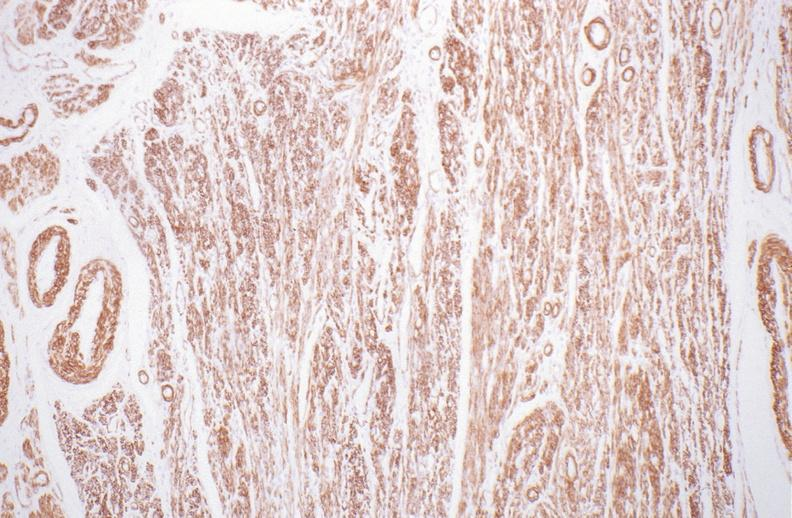where is this from?
Answer the question using a single word or phrase. Female reproductive system 